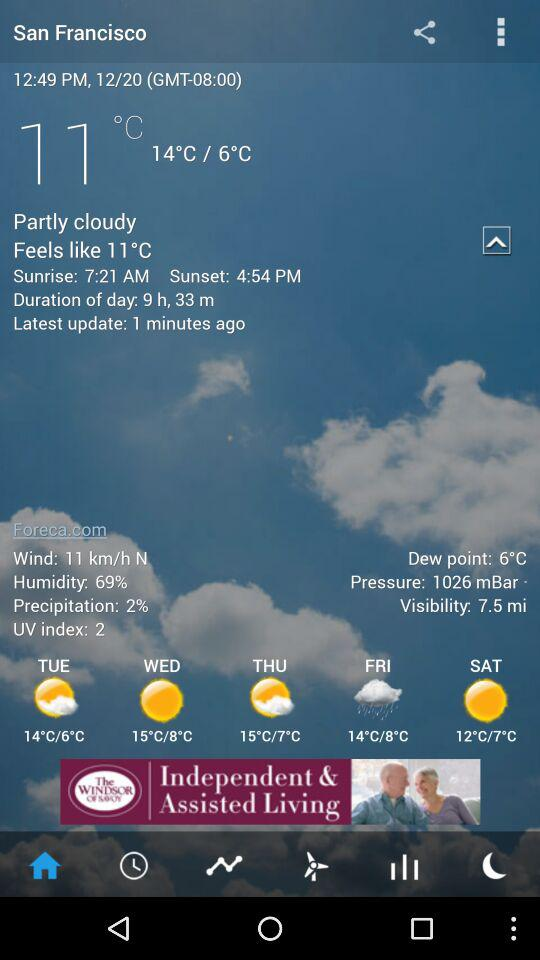What is the date? The date is December 20. 